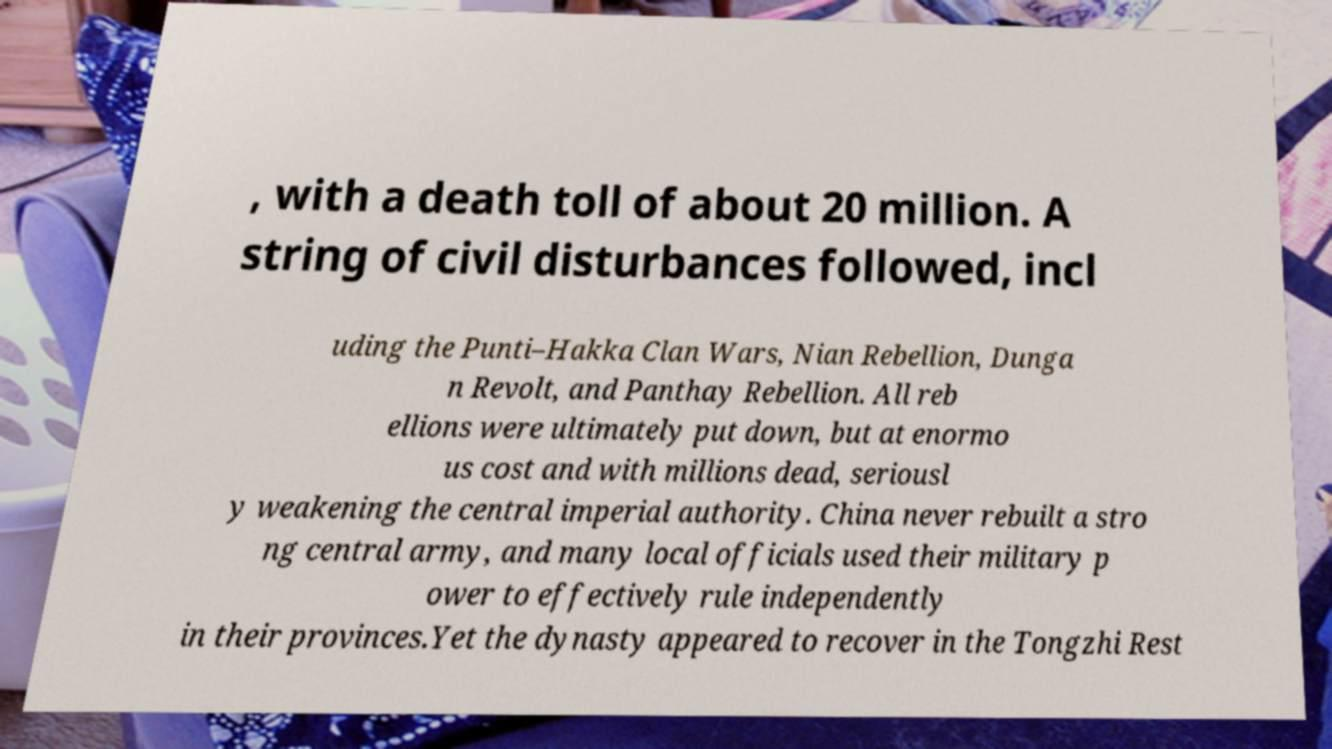Please identify and transcribe the text found in this image. , with a death toll of about 20 million. A string of civil disturbances followed, incl uding the Punti–Hakka Clan Wars, Nian Rebellion, Dunga n Revolt, and Panthay Rebellion. All reb ellions were ultimately put down, but at enormo us cost and with millions dead, seriousl y weakening the central imperial authority. China never rebuilt a stro ng central army, and many local officials used their military p ower to effectively rule independently in their provinces.Yet the dynasty appeared to recover in the Tongzhi Rest 